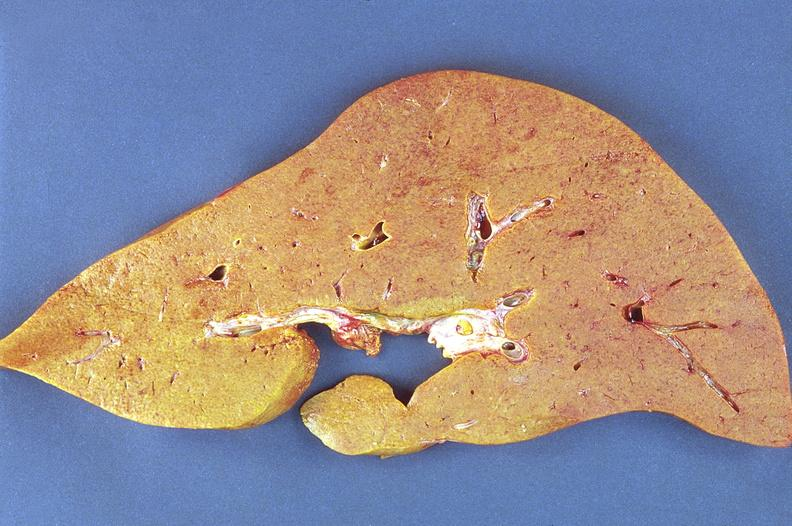does hemorrhagic corpus luteum show amyloidosis?
Answer the question using a single word or phrase. No 